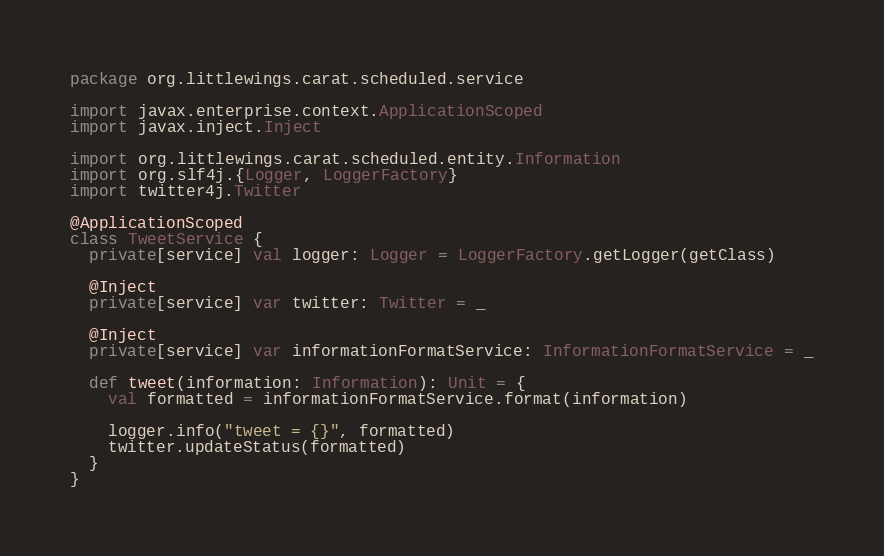<code> <loc_0><loc_0><loc_500><loc_500><_Scala_>package org.littlewings.carat.scheduled.service

import javax.enterprise.context.ApplicationScoped
import javax.inject.Inject

import org.littlewings.carat.scheduled.entity.Information
import org.slf4j.{Logger, LoggerFactory}
import twitter4j.Twitter

@ApplicationScoped
class TweetService {
  private[service] val logger: Logger = LoggerFactory.getLogger(getClass)

  @Inject
  private[service] var twitter: Twitter = _

  @Inject
  private[service] var informationFormatService: InformationFormatService = _

  def tweet(information: Information): Unit = {
    val formatted = informationFormatService.format(information)

    logger.info("tweet = {}", formatted)
    twitter.updateStatus(formatted)
  }
}
</code> 